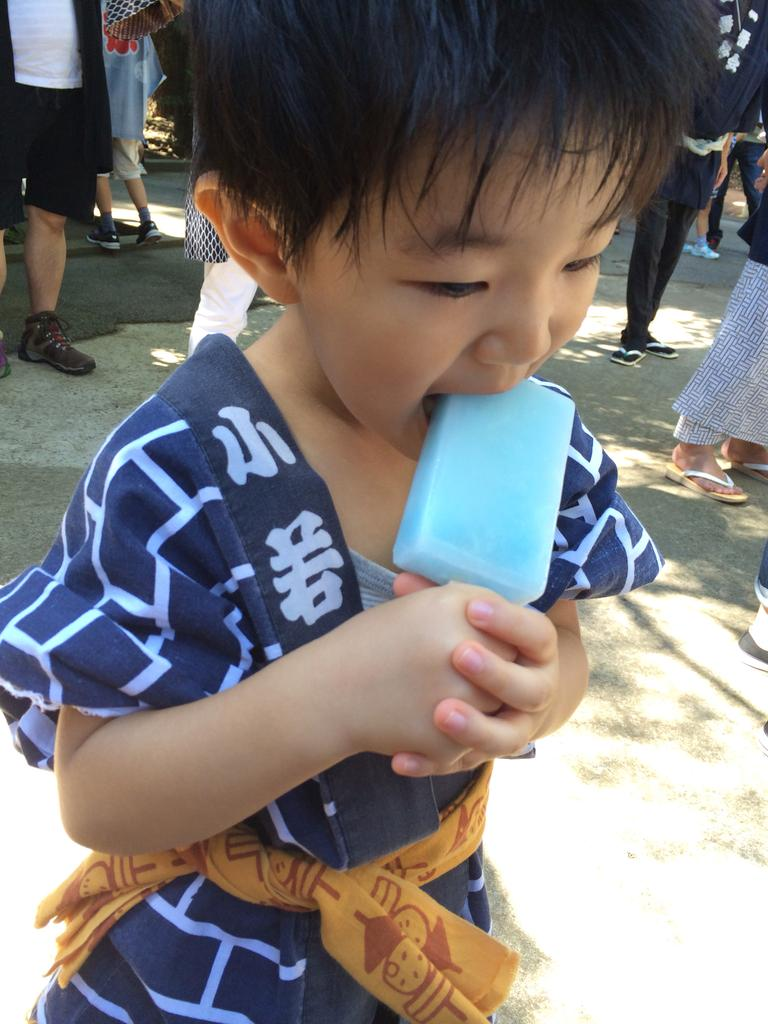What is the main subject of the image? The main subject of the image is a kid. What is the kid doing in the image? The kid is licking an ice-cream. Can you describe the kid's clothing? The kid is wearing blue-colored clothing. Are there any other people in the image? Yes, there are people standing behind the kid. What type of silk is being used to make the children's clothes in the image? There are no children mentioned in the image, and no reference to silk or clothing materials. 